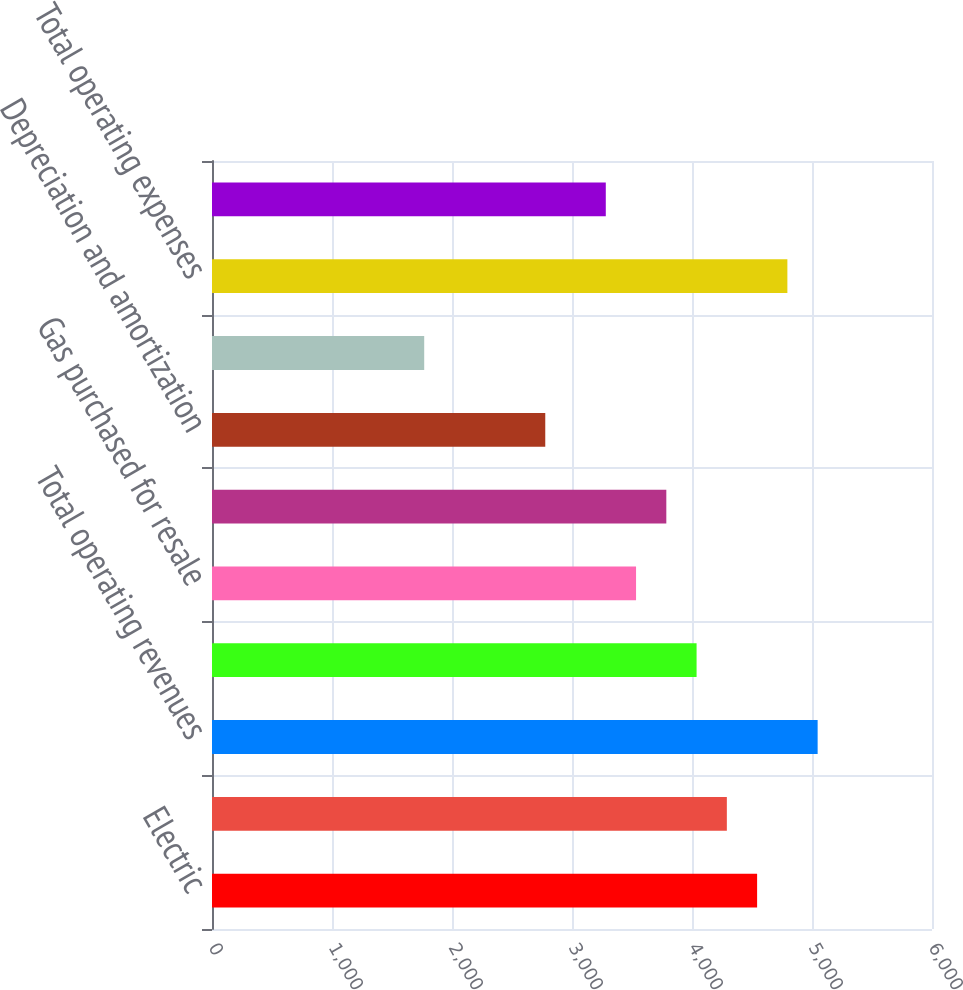<chart> <loc_0><loc_0><loc_500><loc_500><bar_chart><fcel>Electric<fcel>Gas<fcel>Total operating revenues<fcel>Purchased power<fcel>Gas purchased for resale<fcel>Other operations and<fcel>Depreciation and amortization<fcel>Taxes other than income taxes<fcel>Total operating expenses<fcel>Operating Income<nl><fcel>4542.6<fcel>4290.4<fcel>5047<fcel>4038.2<fcel>3533.8<fcel>3786<fcel>2777.2<fcel>1768.4<fcel>4794.8<fcel>3281.6<nl></chart> 